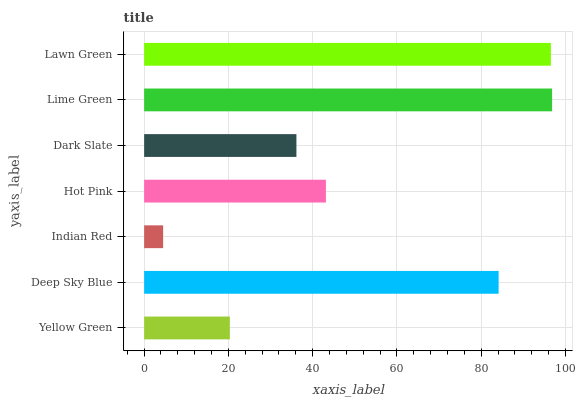Is Indian Red the minimum?
Answer yes or no. Yes. Is Lime Green the maximum?
Answer yes or no. Yes. Is Deep Sky Blue the minimum?
Answer yes or no. No. Is Deep Sky Blue the maximum?
Answer yes or no. No. Is Deep Sky Blue greater than Yellow Green?
Answer yes or no. Yes. Is Yellow Green less than Deep Sky Blue?
Answer yes or no. Yes. Is Yellow Green greater than Deep Sky Blue?
Answer yes or no. No. Is Deep Sky Blue less than Yellow Green?
Answer yes or no. No. Is Hot Pink the high median?
Answer yes or no. Yes. Is Hot Pink the low median?
Answer yes or no. Yes. Is Yellow Green the high median?
Answer yes or no. No. Is Deep Sky Blue the low median?
Answer yes or no. No. 